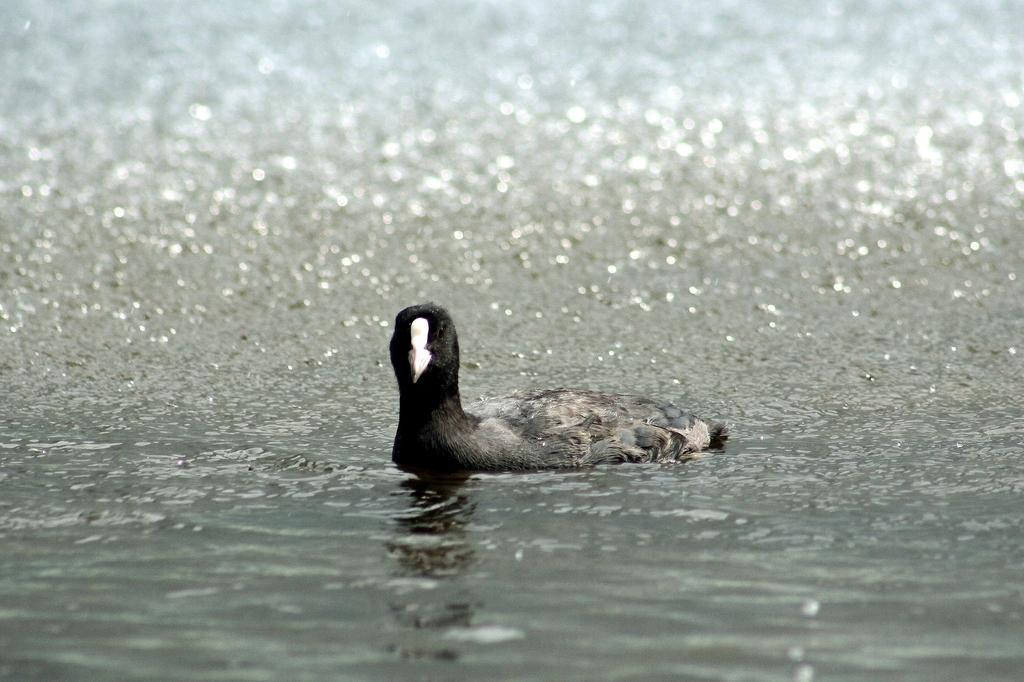Describe this image in one or two sentences. Here in this picture we can see a duck present over the place, which is covered with water all over there. 